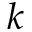<formula> <loc_0><loc_0><loc_500><loc_500>k</formula> 